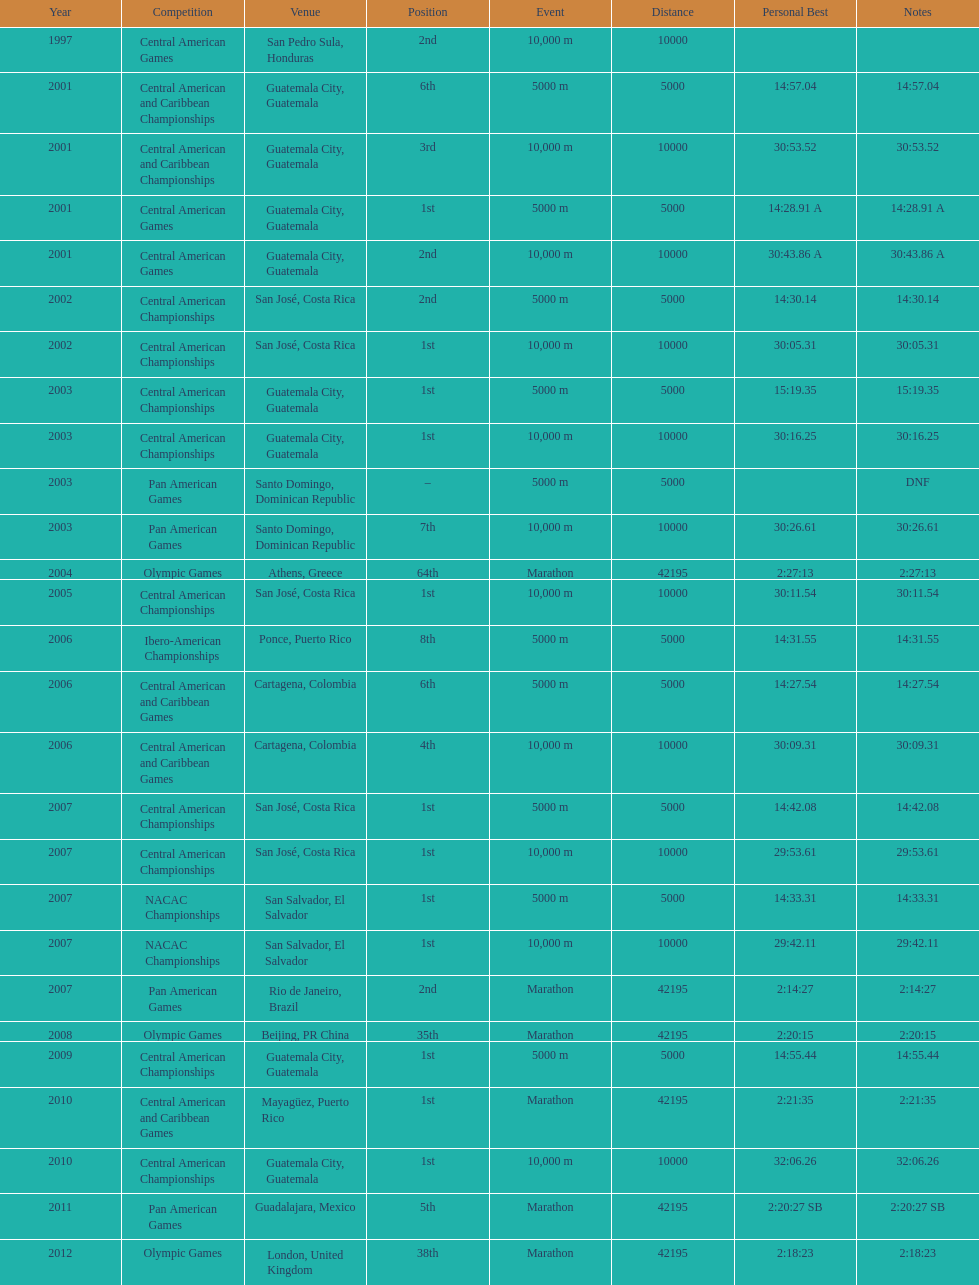How many times has the position of 1st been achieved? 12. 